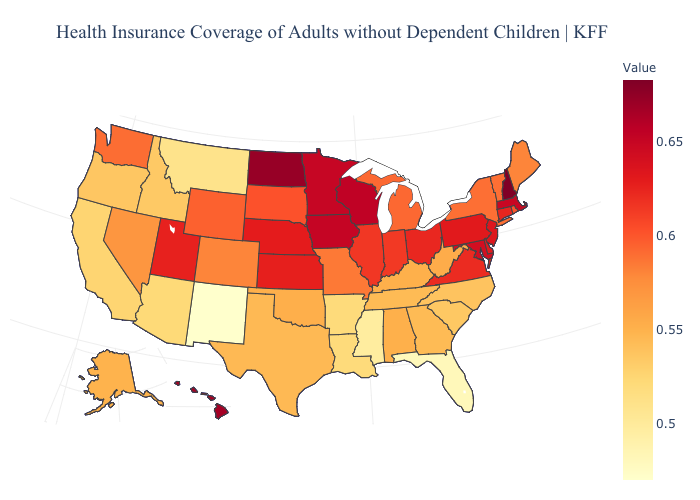Does Rhode Island have a higher value than Massachusetts?
Keep it brief. No. Does Missouri have the lowest value in the USA?
Short answer required. No. Among the states that border Illinois , which have the lowest value?
Answer briefly. Kentucky. Does Rhode Island have a lower value than West Virginia?
Be succinct. No. Which states have the lowest value in the USA?
Answer briefly. New Mexico. Does the map have missing data?
Write a very short answer. No. 